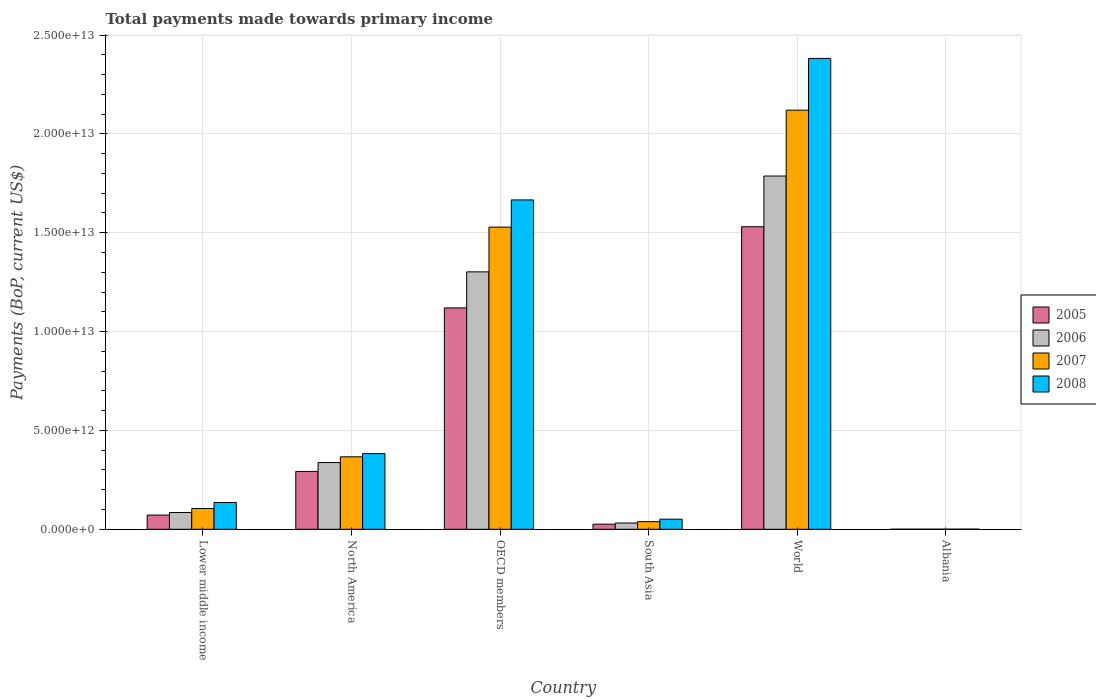How many different coloured bars are there?
Your answer should be very brief. 4. Are the number of bars per tick equal to the number of legend labels?
Give a very brief answer. Yes. What is the label of the 1st group of bars from the left?
Give a very brief answer. Lower middle income. What is the total payments made towards primary income in 2008 in North America?
Keep it short and to the point. 3.83e+12. Across all countries, what is the maximum total payments made towards primary income in 2008?
Your answer should be compact. 2.38e+13. Across all countries, what is the minimum total payments made towards primary income in 2005?
Your answer should be compact. 3.55e+09. In which country was the total payments made towards primary income in 2007 maximum?
Provide a short and direct response. World. In which country was the total payments made towards primary income in 2005 minimum?
Your answer should be very brief. Albania. What is the total total payments made towards primary income in 2006 in the graph?
Your answer should be compact. 3.54e+13. What is the difference between the total payments made towards primary income in 2008 in Albania and that in World?
Keep it short and to the point. -2.38e+13. What is the difference between the total payments made towards primary income in 2006 in North America and the total payments made towards primary income in 2005 in World?
Ensure brevity in your answer.  -1.19e+13. What is the average total payments made towards primary income in 2006 per country?
Give a very brief answer. 5.91e+12. What is the difference between the total payments made towards primary income of/in 2006 and total payments made towards primary income of/in 2007 in OECD members?
Your answer should be compact. -2.26e+12. In how many countries, is the total payments made towards primary income in 2005 greater than 18000000000000 US$?
Provide a succinct answer. 0. What is the ratio of the total payments made towards primary income in 2006 in North America to that in World?
Your response must be concise. 0.19. Is the difference between the total payments made towards primary income in 2006 in Lower middle income and North America greater than the difference between the total payments made towards primary income in 2007 in Lower middle income and North America?
Your response must be concise. Yes. What is the difference between the highest and the second highest total payments made towards primary income in 2005?
Your answer should be very brief. 8.27e+12. What is the difference between the highest and the lowest total payments made towards primary income in 2006?
Give a very brief answer. 1.79e+13. In how many countries, is the total payments made towards primary income in 2007 greater than the average total payments made towards primary income in 2007 taken over all countries?
Your answer should be very brief. 2. Is the sum of the total payments made towards primary income in 2007 in OECD members and World greater than the maximum total payments made towards primary income in 2005 across all countries?
Offer a very short reply. Yes. What does the 2nd bar from the right in South Asia represents?
Your answer should be very brief. 2007. Is it the case that in every country, the sum of the total payments made towards primary income in 2005 and total payments made towards primary income in 2008 is greater than the total payments made towards primary income in 2006?
Your answer should be compact. Yes. How many bars are there?
Ensure brevity in your answer.  24. What is the difference between two consecutive major ticks on the Y-axis?
Keep it short and to the point. 5.00e+12. Does the graph contain any zero values?
Give a very brief answer. No. Does the graph contain grids?
Provide a succinct answer. Yes. Where does the legend appear in the graph?
Your response must be concise. Center right. How many legend labels are there?
Offer a very short reply. 4. How are the legend labels stacked?
Give a very brief answer. Vertical. What is the title of the graph?
Offer a terse response. Total payments made towards primary income. What is the label or title of the Y-axis?
Your answer should be compact. Payments (BoP, current US$). What is the Payments (BoP, current US$) in 2005 in Lower middle income?
Give a very brief answer. 7.19e+11. What is the Payments (BoP, current US$) of 2006 in Lower middle income?
Ensure brevity in your answer.  8.48e+11. What is the Payments (BoP, current US$) in 2007 in Lower middle income?
Your answer should be very brief. 1.05e+12. What is the Payments (BoP, current US$) of 2008 in Lower middle income?
Make the answer very short. 1.35e+12. What is the Payments (BoP, current US$) in 2005 in North America?
Your answer should be compact. 2.93e+12. What is the Payments (BoP, current US$) in 2006 in North America?
Keep it short and to the point. 3.38e+12. What is the Payments (BoP, current US$) in 2007 in North America?
Offer a terse response. 3.67e+12. What is the Payments (BoP, current US$) of 2008 in North America?
Give a very brief answer. 3.83e+12. What is the Payments (BoP, current US$) in 2005 in OECD members?
Provide a succinct answer. 1.12e+13. What is the Payments (BoP, current US$) in 2006 in OECD members?
Give a very brief answer. 1.30e+13. What is the Payments (BoP, current US$) of 2007 in OECD members?
Provide a short and direct response. 1.53e+13. What is the Payments (BoP, current US$) of 2008 in OECD members?
Provide a succinct answer. 1.67e+13. What is the Payments (BoP, current US$) in 2005 in South Asia?
Your answer should be compact. 2.61e+11. What is the Payments (BoP, current US$) of 2006 in South Asia?
Offer a very short reply. 3.18e+11. What is the Payments (BoP, current US$) in 2007 in South Asia?
Ensure brevity in your answer.  3.88e+11. What is the Payments (BoP, current US$) in 2008 in South Asia?
Keep it short and to the point. 5.11e+11. What is the Payments (BoP, current US$) in 2005 in World?
Make the answer very short. 1.53e+13. What is the Payments (BoP, current US$) of 2006 in World?
Provide a succinct answer. 1.79e+13. What is the Payments (BoP, current US$) of 2007 in World?
Provide a short and direct response. 2.12e+13. What is the Payments (BoP, current US$) in 2008 in World?
Your response must be concise. 2.38e+13. What is the Payments (BoP, current US$) of 2005 in Albania?
Your answer should be compact. 3.55e+09. What is the Payments (BoP, current US$) in 2006 in Albania?
Give a very brief answer. 4.14e+09. What is the Payments (BoP, current US$) of 2007 in Albania?
Provide a short and direct response. 5.43e+09. What is the Payments (BoP, current US$) in 2008 in Albania?
Provide a short and direct response. 7.15e+09. Across all countries, what is the maximum Payments (BoP, current US$) of 2005?
Provide a short and direct response. 1.53e+13. Across all countries, what is the maximum Payments (BoP, current US$) of 2006?
Keep it short and to the point. 1.79e+13. Across all countries, what is the maximum Payments (BoP, current US$) of 2007?
Offer a terse response. 2.12e+13. Across all countries, what is the maximum Payments (BoP, current US$) of 2008?
Give a very brief answer. 2.38e+13. Across all countries, what is the minimum Payments (BoP, current US$) of 2005?
Provide a short and direct response. 3.55e+09. Across all countries, what is the minimum Payments (BoP, current US$) in 2006?
Your answer should be compact. 4.14e+09. Across all countries, what is the minimum Payments (BoP, current US$) in 2007?
Your response must be concise. 5.43e+09. Across all countries, what is the minimum Payments (BoP, current US$) of 2008?
Provide a short and direct response. 7.15e+09. What is the total Payments (BoP, current US$) of 2005 in the graph?
Offer a terse response. 3.04e+13. What is the total Payments (BoP, current US$) in 2006 in the graph?
Provide a short and direct response. 3.54e+13. What is the total Payments (BoP, current US$) of 2007 in the graph?
Provide a succinct answer. 4.16e+13. What is the total Payments (BoP, current US$) in 2008 in the graph?
Make the answer very short. 4.62e+13. What is the difference between the Payments (BoP, current US$) in 2005 in Lower middle income and that in North America?
Give a very brief answer. -2.21e+12. What is the difference between the Payments (BoP, current US$) in 2006 in Lower middle income and that in North America?
Provide a short and direct response. -2.53e+12. What is the difference between the Payments (BoP, current US$) of 2007 in Lower middle income and that in North America?
Provide a succinct answer. -2.61e+12. What is the difference between the Payments (BoP, current US$) in 2008 in Lower middle income and that in North America?
Offer a very short reply. -2.47e+12. What is the difference between the Payments (BoP, current US$) in 2005 in Lower middle income and that in OECD members?
Offer a very short reply. -1.05e+13. What is the difference between the Payments (BoP, current US$) of 2006 in Lower middle income and that in OECD members?
Offer a very short reply. -1.22e+13. What is the difference between the Payments (BoP, current US$) of 2007 in Lower middle income and that in OECD members?
Your answer should be very brief. -1.42e+13. What is the difference between the Payments (BoP, current US$) in 2008 in Lower middle income and that in OECD members?
Your answer should be very brief. -1.53e+13. What is the difference between the Payments (BoP, current US$) of 2005 in Lower middle income and that in South Asia?
Make the answer very short. 4.59e+11. What is the difference between the Payments (BoP, current US$) in 2006 in Lower middle income and that in South Asia?
Your answer should be compact. 5.30e+11. What is the difference between the Payments (BoP, current US$) in 2007 in Lower middle income and that in South Asia?
Your answer should be compact. 6.64e+11. What is the difference between the Payments (BoP, current US$) of 2008 in Lower middle income and that in South Asia?
Make the answer very short. 8.43e+11. What is the difference between the Payments (BoP, current US$) in 2005 in Lower middle income and that in World?
Give a very brief answer. -1.46e+13. What is the difference between the Payments (BoP, current US$) of 2006 in Lower middle income and that in World?
Your answer should be compact. -1.70e+13. What is the difference between the Payments (BoP, current US$) in 2007 in Lower middle income and that in World?
Keep it short and to the point. -2.01e+13. What is the difference between the Payments (BoP, current US$) of 2008 in Lower middle income and that in World?
Provide a short and direct response. -2.25e+13. What is the difference between the Payments (BoP, current US$) in 2005 in Lower middle income and that in Albania?
Offer a very short reply. 7.16e+11. What is the difference between the Payments (BoP, current US$) in 2006 in Lower middle income and that in Albania?
Offer a very short reply. 8.44e+11. What is the difference between the Payments (BoP, current US$) of 2007 in Lower middle income and that in Albania?
Offer a very short reply. 1.05e+12. What is the difference between the Payments (BoP, current US$) in 2008 in Lower middle income and that in Albania?
Your answer should be very brief. 1.35e+12. What is the difference between the Payments (BoP, current US$) in 2005 in North America and that in OECD members?
Provide a succinct answer. -8.27e+12. What is the difference between the Payments (BoP, current US$) in 2006 in North America and that in OECD members?
Your answer should be compact. -9.65e+12. What is the difference between the Payments (BoP, current US$) of 2007 in North America and that in OECD members?
Make the answer very short. -1.16e+13. What is the difference between the Payments (BoP, current US$) in 2008 in North America and that in OECD members?
Your answer should be very brief. -1.28e+13. What is the difference between the Payments (BoP, current US$) of 2005 in North America and that in South Asia?
Your answer should be very brief. 2.67e+12. What is the difference between the Payments (BoP, current US$) in 2006 in North America and that in South Asia?
Provide a succinct answer. 3.06e+12. What is the difference between the Payments (BoP, current US$) of 2007 in North America and that in South Asia?
Provide a succinct answer. 3.28e+12. What is the difference between the Payments (BoP, current US$) of 2008 in North America and that in South Asia?
Provide a succinct answer. 3.32e+12. What is the difference between the Payments (BoP, current US$) of 2005 in North America and that in World?
Keep it short and to the point. -1.24e+13. What is the difference between the Payments (BoP, current US$) in 2006 in North America and that in World?
Keep it short and to the point. -1.45e+13. What is the difference between the Payments (BoP, current US$) in 2007 in North America and that in World?
Your response must be concise. -1.75e+13. What is the difference between the Payments (BoP, current US$) in 2008 in North America and that in World?
Your answer should be compact. -2.00e+13. What is the difference between the Payments (BoP, current US$) of 2005 in North America and that in Albania?
Provide a succinct answer. 2.92e+12. What is the difference between the Payments (BoP, current US$) in 2006 in North America and that in Albania?
Offer a terse response. 3.37e+12. What is the difference between the Payments (BoP, current US$) in 2007 in North America and that in Albania?
Give a very brief answer. 3.66e+12. What is the difference between the Payments (BoP, current US$) in 2008 in North America and that in Albania?
Keep it short and to the point. 3.82e+12. What is the difference between the Payments (BoP, current US$) of 2005 in OECD members and that in South Asia?
Offer a very short reply. 1.09e+13. What is the difference between the Payments (BoP, current US$) in 2006 in OECD members and that in South Asia?
Offer a terse response. 1.27e+13. What is the difference between the Payments (BoP, current US$) in 2007 in OECD members and that in South Asia?
Offer a terse response. 1.49e+13. What is the difference between the Payments (BoP, current US$) in 2008 in OECD members and that in South Asia?
Your answer should be very brief. 1.61e+13. What is the difference between the Payments (BoP, current US$) in 2005 in OECD members and that in World?
Offer a very short reply. -4.11e+12. What is the difference between the Payments (BoP, current US$) of 2006 in OECD members and that in World?
Offer a very short reply. -4.85e+12. What is the difference between the Payments (BoP, current US$) of 2007 in OECD members and that in World?
Provide a short and direct response. -5.91e+12. What is the difference between the Payments (BoP, current US$) in 2008 in OECD members and that in World?
Your answer should be very brief. -7.16e+12. What is the difference between the Payments (BoP, current US$) in 2005 in OECD members and that in Albania?
Provide a succinct answer. 1.12e+13. What is the difference between the Payments (BoP, current US$) of 2006 in OECD members and that in Albania?
Ensure brevity in your answer.  1.30e+13. What is the difference between the Payments (BoP, current US$) in 2007 in OECD members and that in Albania?
Your answer should be compact. 1.53e+13. What is the difference between the Payments (BoP, current US$) in 2008 in OECD members and that in Albania?
Provide a succinct answer. 1.67e+13. What is the difference between the Payments (BoP, current US$) in 2005 in South Asia and that in World?
Your response must be concise. -1.50e+13. What is the difference between the Payments (BoP, current US$) of 2006 in South Asia and that in World?
Your answer should be compact. -1.75e+13. What is the difference between the Payments (BoP, current US$) in 2007 in South Asia and that in World?
Provide a short and direct response. -2.08e+13. What is the difference between the Payments (BoP, current US$) of 2008 in South Asia and that in World?
Your answer should be very brief. -2.33e+13. What is the difference between the Payments (BoP, current US$) in 2005 in South Asia and that in Albania?
Ensure brevity in your answer.  2.57e+11. What is the difference between the Payments (BoP, current US$) in 2006 in South Asia and that in Albania?
Your answer should be compact. 3.14e+11. What is the difference between the Payments (BoP, current US$) in 2007 in South Asia and that in Albania?
Offer a terse response. 3.82e+11. What is the difference between the Payments (BoP, current US$) in 2008 in South Asia and that in Albania?
Keep it short and to the point. 5.04e+11. What is the difference between the Payments (BoP, current US$) in 2005 in World and that in Albania?
Make the answer very short. 1.53e+13. What is the difference between the Payments (BoP, current US$) of 2006 in World and that in Albania?
Your response must be concise. 1.79e+13. What is the difference between the Payments (BoP, current US$) in 2007 in World and that in Albania?
Provide a short and direct response. 2.12e+13. What is the difference between the Payments (BoP, current US$) in 2008 in World and that in Albania?
Offer a terse response. 2.38e+13. What is the difference between the Payments (BoP, current US$) in 2005 in Lower middle income and the Payments (BoP, current US$) in 2006 in North America?
Provide a succinct answer. -2.66e+12. What is the difference between the Payments (BoP, current US$) of 2005 in Lower middle income and the Payments (BoP, current US$) of 2007 in North America?
Your answer should be compact. -2.95e+12. What is the difference between the Payments (BoP, current US$) in 2005 in Lower middle income and the Payments (BoP, current US$) in 2008 in North America?
Offer a terse response. -3.11e+12. What is the difference between the Payments (BoP, current US$) of 2006 in Lower middle income and the Payments (BoP, current US$) of 2007 in North America?
Your answer should be compact. -2.82e+12. What is the difference between the Payments (BoP, current US$) of 2006 in Lower middle income and the Payments (BoP, current US$) of 2008 in North America?
Your answer should be very brief. -2.98e+12. What is the difference between the Payments (BoP, current US$) of 2007 in Lower middle income and the Payments (BoP, current US$) of 2008 in North America?
Keep it short and to the point. -2.78e+12. What is the difference between the Payments (BoP, current US$) of 2005 in Lower middle income and the Payments (BoP, current US$) of 2006 in OECD members?
Give a very brief answer. -1.23e+13. What is the difference between the Payments (BoP, current US$) in 2005 in Lower middle income and the Payments (BoP, current US$) in 2007 in OECD members?
Provide a succinct answer. -1.46e+13. What is the difference between the Payments (BoP, current US$) of 2005 in Lower middle income and the Payments (BoP, current US$) of 2008 in OECD members?
Your answer should be compact. -1.59e+13. What is the difference between the Payments (BoP, current US$) in 2006 in Lower middle income and the Payments (BoP, current US$) in 2007 in OECD members?
Your answer should be compact. -1.44e+13. What is the difference between the Payments (BoP, current US$) of 2006 in Lower middle income and the Payments (BoP, current US$) of 2008 in OECD members?
Offer a terse response. -1.58e+13. What is the difference between the Payments (BoP, current US$) of 2007 in Lower middle income and the Payments (BoP, current US$) of 2008 in OECD members?
Make the answer very short. -1.56e+13. What is the difference between the Payments (BoP, current US$) of 2005 in Lower middle income and the Payments (BoP, current US$) of 2006 in South Asia?
Ensure brevity in your answer.  4.01e+11. What is the difference between the Payments (BoP, current US$) of 2005 in Lower middle income and the Payments (BoP, current US$) of 2007 in South Asia?
Offer a terse response. 3.32e+11. What is the difference between the Payments (BoP, current US$) in 2005 in Lower middle income and the Payments (BoP, current US$) in 2008 in South Asia?
Keep it short and to the point. 2.08e+11. What is the difference between the Payments (BoP, current US$) in 2006 in Lower middle income and the Payments (BoP, current US$) in 2007 in South Asia?
Ensure brevity in your answer.  4.60e+11. What is the difference between the Payments (BoP, current US$) in 2006 in Lower middle income and the Payments (BoP, current US$) in 2008 in South Asia?
Make the answer very short. 3.37e+11. What is the difference between the Payments (BoP, current US$) of 2007 in Lower middle income and the Payments (BoP, current US$) of 2008 in South Asia?
Your answer should be compact. 5.41e+11. What is the difference between the Payments (BoP, current US$) in 2005 in Lower middle income and the Payments (BoP, current US$) in 2006 in World?
Keep it short and to the point. -1.71e+13. What is the difference between the Payments (BoP, current US$) in 2005 in Lower middle income and the Payments (BoP, current US$) in 2007 in World?
Offer a terse response. -2.05e+13. What is the difference between the Payments (BoP, current US$) of 2005 in Lower middle income and the Payments (BoP, current US$) of 2008 in World?
Offer a terse response. -2.31e+13. What is the difference between the Payments (BoP, current US$) of 2006 in Lower middle income and the Payments (BoP, current US$) of 2007 in World?
Your response must be concise. -2.04e+13. What is the difference between the Payments (BoP, current US$) of 2006 in Lower middle income and the Payments (BoP, current US$) of 2008 in World?
Keep it short and to the point. -2.30e+13. What is the difference between the Payments (BoP, current US$) in 2007 in Lower middle income and the Payments (BoP, current US$) in 2008 in World?
Ensure brevity in your answer.  -2.28e+13. What is the difference between the Payments (BoP, current US$) in 2005 in Lower middle income and the Payments (BoP, current US$) in 2006 in Albania?
Your answer should be very brief. 7.15e+11. What is the difference between the Payments (BoP, current US$) in 2005 in Lower middle income and the Payments (BoP, current US$) in 2007 in Albania?
Offer a terse response. 7.14e+11. What is the difference between the Payments (BoP, current US$) of 2005 in Lower middle income and the Payments (BoP, current US$) of 2008 in Albania?
Your answer should be compact. 7.12e+11. What is the difference between the Payments (BoP, current US$) in 2006 in Lower middle income and the Payments (BoP, current US$) in 2007 in Albania?
Ensure brevity in your answer.  8.42e+11. What is the difference between the Payments (BoP, current US$) in 2006 in Lower middle income and the Payments (BoP, current US$) in 2008 in Albania?
Your answer should be compact. 8.41e+11. What is the difference between the Payments (BoP, current US$) in 2007 in Lower middle income and the Payments (BoP, current US$) in 2008 in Albania?
Ensure brevity in your answer.  1.04e+12. What is the difference between the Payments (BoP, current US$) of 2005 in North America and the Payments (BoP, current US$) of 2006 in OECD members?
Your answer should be very brief. -1.01e+13. What is the difference between the Payments (BoP, current US$) of 2005 in North America and the Payments (BoP, current US$) of 2007 in OECD members?
Offer a terse response. -1.24e+13. What is the difference between the Payments (BoP, current US$) in 2005 in North America and the Payments (BoP, current US$) in 2008 in OECD members?
Provide a short and direct response. -1.37e+13. What is the difference between the Payments (BoP, current US$) in 2006 in North America and the Payments (BoP, current US$) in 2007 in OECD members?
Offer a terse response. -1.19e+13. What is the difference between the Payments (BoP, current US$) of 2006 in North America and the Payments (BoP, current US$) of 2008 in OECD members?
Keep it short and to the point. -1.33e+13. What is the difference between the Payments (BoP, current US$) in 2007 in North America and the Payments (BoP, current US$) in 2008 in OECD members?
Provide a short and direct response. -1.30e+13. What is the difference between the Payments (BoP, current US$) in 2005 in North America and the Payments (BoP, current US$) in 2006 in South Asia?
Offer a terse response. 2.61e+12. What is the difference between the Payments (BoP, current US$) of 2005 in North America and the Payments (BoP, current US$) of 2007 in South Asia?
Provide a short and direct response. 2.54e+12. What is the difference between the Payments (BoP, current US$) in 2005 in North America and the Payments (BoP, current US$) in 2008 in South Asia?
Provide a succinct answer. 2.41e+12. What is the difference between the Payments (BoP, current US$) in 2006 in North America and the Payments (BoP, current US$) in 2007 in South Asia?
Offer a very short reply. 2.99e+12. What is the difference between the Payments (BoP, current US$) of 2006 in North America and the Payments (BoP, current US$) of 2008 in South Asia?
Ensure brevity in your answer.  2.86e+12. What is the difference between the Payments (BoP, current US$) of 2007 in North America and the Payments (BoP, current US$) of 2008 in South Asia?
Provide a short and direct response. 3.15e+12. What is the difference between the Payments (BoP, current US$) of 2005 in North America and the Payments (BoP, current US$) of 2006 in World?
Offer a very short reply. -1.49e+13. What is the difference between the Payments (BoP, current US$) of 2005 in North America and the Payments (BoP, current US$) of 2007 in World?
Provide a short and direct response. -1.83e+13. What is the difference between the Payments (BoP, current US$) of 2005 in North America and the Payments (BoP, current US$) of 2008 in World?
Keep it short and to the point. -2.09e+13. What is the difference between the Payments (BoP, current US$) of 2006 in North America and the Payments (BoP, current US$) of 2007 in World?
Offer a very short reply. -1.78e+13. What is the difference between the Payments (BoP, current US$) of 2006 in North America and the Payments (BoP, current US$) of 2008 in World?
Provide a short and direct response. -2.04e+13. What is the difference between the Payments (BoP, current US$) in 2007 in North America and the Payments (BoP, current US$) in 2008 in World?
Your response must be concise. -2.01e+13. What is the difference between the Payments (BoP, current US$) in 2005 in North America and the Payments (BoP, current US$) in 2006 in Albania?
Your response must be concise. 2.92e+12. What is the difference between the Payments (BoP, current US$) in 2005 in North America and the Payments (BoP, current US$) in 2007 in Albania?
Give a very brief answer. 2.92e+12. What is the difference between the Payments (BoP, current US$) in 2005 in North America and the Payments (BoP, current US$) in 2008 in Albania?
Your response must be concise. 2.92e+12. What is the difference between the Payments (BoP, current US$) of 2006 in North America and the Payments (BoP, current US$) of 2007 in Albania?
Provide a succinct answer. 3.37e+12. What is the difference between the Payments (BoP, current US$) in 2006 in North America and the Payments (BoP, current US$) in 2008 in Albania?
Your response must be concise. 3.37e+12. What is the difference between the Payments (BoP, current US$) of 2007 in North America and the Payments (BoP, current US$) of 2008 in Albania?
Ensure brevity in your answer.  3.66e+12. What is the difference between the Payments (BoP, current US$) of 2005 in OECD members and the Payments (BoP, current US$) of 2006 in South Asia?
Your answer should be compact. 1.09e+13. What is the difference between the Payments (BoP, current US$) of 2005 in OECD members and the Payments (BoP, current US$) of 2007 in South Asia?
Offer a very short reply. 1.08e+13. What is the difference between the Payments (BoP, current US$) in 2005 in OECD members and the Payments (BoP, current US$) in 2008 in South Asia?
Offer a terse response. 1.07e+13. What is the difference between the Payments (BoP, current US$) in 2006 in OECD members and the Payments (BoP, current US$) in 2007 in South Asia?
Provide a succinct answer. 1.26e+13. What is the difference between the Payments (BoP, current US$) in 2006 in OECD members and the Payments (BoP, current US$) in 2008 in South Asia?
Make the answer very short. 1.25e+13. What is the difference between the Payments (BoP, current US$) in 2007 in OECD members and the Payments (BoP, current US$) in 2008 in South Asia?
Give a very brief answer. 1.48e+13. What is the difference between the Payments (BoP, current US$) in 2005 in OECD members and the Payments (BoP, current US$) in 2006 in World?
Offer a very short reply. -6.67e+12. What is the difference between the Payments (BoP, current US$) in 2005 in OECD members and the Payments (BoP, current US$) in 2007 in World?
Your answer should be compact. -1.00e+13. What is the difference between the Payments (BoP, current US$) in 2005 in OECD members and the Payments (BoP, current US$) in 2008 in World?
Your answer should be compact. -1.26e+13. What is the difference between the Payments (BoP, current US$) of 2006 in OECD members and the Payments (BoP, current US$) of 2007 in World?
Ensure brevity in your answer.  -8.18e+12. What is the difference between the Payments (BoP, current US$) of 2006 in OECD members and the Payments (BoP, current US$) of 2008 in World?
Your response must be concise. -1.08e+13. What is the difference between the Payments (BoP, current US$) of 2007 in OECD members and the Payments (BoP, current US$) of 2008 in World?
Ensure brevity in your answer.  -8.53e+12. What is the difference between the Payments (BoP, current US$) in 2005 in OECD members and the Payments (BoP, current US$) in 2006 in Albania?
Provide a succinct answer. 1.12e+13. What is the difference between the Payments (BoP, current US$) of 2005 in OECD members and the Payments (BoP, current US$) of 2007 in Albania?
Provide a short and direct response. 1.12e+13. What is the difference between the Payments (BoP, current US$) of 2005 in OECD members and the Payments (BoP, current US$) of 2008 in Albania?
Your answer should be very brief. 1.12e+13. What is the difference between the Payments (BoP, current US$) of 2006 in OECD members and the Payments (BoP, current US$) of 2007 in Albania?
Ensure brevity in your answer.  1.30e+13. What is the difference between the Payments (BoP, current US$) in 2006 in OECD members and the Payments (BoP, current US$) in 2008 in Albania?
Offer a terse response. 1.30e+13. What is the difference between the Payments (BoP, current US$) of 2007 in OECD members and the Payments (BoP, current US$) of 2008 in Albania?
Your response must be concise. 1.53e+13. What is the difference between the Payments (BoP, current US$) in 2005 in South Asia and the Payments (BoP, current US$) in 2006 in World?
Ensure brevity in your answer.  -1.76e+13. What is the difference between the Payments (BoP, current US$) in 2005 in South Asia and the Payments (BoP, current US$) in 2007 in World?
Ensure brevity in your answer.  -2.09e+13. What is the difference between the Payments (BoP, current US$) in 2005 in South Asia and the Payments (BoP, current US$) in 2008 in World?
Provide a succinct answer. -2.36e+13. What is the difference between the Payments (BoP, current US$) of 2006 in South Asia and the Payments (BoP, current US$) of 2007 in World?
Provide a short and direct response. -2.09e+13. What is the difference between the Payments (BoP, current US$) of 2006 in South Asia and the Payments (BoP, current US$) of 2008 in World?
Your answer should be compact. -2.35e+13. What is the difference between the Payments (BoP, current US$) of 2007 in South Asia and the Payments (BoP, current US$) of 2008 in World?
Offer a very short reply. -2.34e+13. What is the difference between the Payments (BoP, current US$) in 2005 in South Asia and the Payments (BoP, current US$) in 2006 in Albania?
Ensure brevity in your answer.  2.56e+11. What is the difference between the Payments (BoP, current US$) in 2005 in South Asia and the Payments (BoP, current US$) in 2007 in Albania?
Provide a short and direct response. 2.55e+11. What is the difference between the Payments (BoP, current US$) in 2005 in South Asia and the Payments (BoP, current US$) in 2008 in Albania?
Your response must be concise. 2.53e+11. What is the difference between the Payments (BoP, current US$) in 2006 in South Asia and the Payments (BoP, current US$) in 2007 in Albania?
Provide a short and direct response. 3.13e+11. What is the difference between the Payments (BoP, current US$) of 2006 in South Asia and the Payments (BoP, current US$) of 2008 in Albania?
Give a very brief answer. 3.11e+11. What is the difference between the Payments (BoP, current US$) in 2007 in South Asia and the Payments (BoP, current US$) in 2008 in Albania?
Ensure brevity in your answer.  3.80e+11. What is the difference between the Payments (BoP, current US$) in 2005 in World and the Payments (BoP, current US$) in 2006 in Albania?
Provide a succinct answer. 1.53e+13. What is the difference between the Payments (BoP, current US$) in 2005 in World and the Payments (BoP, current US$) in 2007 in Albania?
Offer a very short reply. 1.53e+13. What is the difference between the Payments (BoP, current US$) of 2005 in World and the Payments (BoP, current US$) of 2008 in Albania?
Offer a terse response. 1.53e+13. What is the difference between the Payments (BoP, current US$) in 2006 in World and the Payments (BoP, current US$) in 2007 in Albania?
Keep it short and to the point. 1.79e+13. What is the difference between the Payments (BoP, current US$) of 2006 in World and the Payments (BoP, current US$) of 2008 in Albania?
Provide a succinct answer. 1.79e+13. What is the difference between the Payments (BoP, current US$) of 2007 in World and the Payments (BoP, current US$) of 2008 in Albania?
Your answer should be very brief. 2.12e+13. What is the average Payments (BoP, current US$) of 2005 per country?
Provide a succinct answer. 5.07e+12. What is the average Payments (BoP, current US$) in 2006 per country?
Your response must be concise. 5.91e+12. What is the average Payments (BoP, current US$) in 2007 per country?
Ensure brevity in your answer.  6.93e+12. What is the average Payments (BoP, current US$) in 2008 per country?
Provide a short and direct response. 7.70e+12. What is the difference between the Payments (BoP, current US$) in 2005 and Payments (BoP, current US$) in 2006 in Lower middle income?
Keep it short and to the point. -1.29e+11. What is the difference between the Payments (BoP, current US$) in 2005 and Payments (BoP, current US$) in 2007 in Lower middle income?
Provide a succinct answer. -3.33e+11. What is the difference between the Payments (BoP, current US$) in 2005 and Payments (BoP, current US$) in 2008 in Lower middle income?
Provide a short and direct response. -6.35e+11. What is the difference between the Payments (BoP, current US$) of 2006 and Payments (BoP, current US$) of 2007 in Lower middle income?
Keep it short and to the point. -2.04e+11. What is the difference between the Payments (BoP, current US$) in 2006 and Payments (BoP, current US$) in 2008 in Lower middle income?
Offer a terse response. -5.07e+11. What is the difference between the Payments (BoP, current US$) in 2007 and Payments (BoP, current US$) in 2008 in Lower middle income?
Give a very brief answer. -3.03e+11. What is the difference between the Payments (BoP, current US$) in 2005 and Payments (BoP, current US$) in 2006 in North America?
Your response must be concise. -4.49e+11. What is the difference between the Payments (BoP, current US$) in 2005 and Payments (BoP, current US$) in 2007 in North America?
Make the answer very short. -7.40e+11. What is the difference between the Payments (BoP, current US$) in 2005 and Payments (BoP, current US$) in 2008 in North America?
Your response must be concise. -9.02e+11. What is the difference between the Payments (BoP, current US$) of 2006 and Payments (BoP, current US$) of 2007 in North America?
Keep it short and to the point. -2.91e+11. What is the difference between the Payments (BoP, current US$) in 2006 and Payments (BoP, current US$) in 2008 in North America?
Provide a succinct answer. -4.53e+11. What is the difference between the Payments (BoP, current US$) in 2007 and Payments (BoP, current US$) in 2008 in North America?
Ensure brevity in your answer.  -1.62e+11. What is the difference between the Payments (BoP, current US$) of 2005 and Payments (BoP, current US$) of 2006 in OECD members?
Give a very brief answer. -1.82e+12. What is the difference between the Payments (BoP, current US$) in 2005 and Payments (BoP, current US$) in 2007 in OECD members?
Your response must be concise. -4.09e+12. What is the difference between the Payments (BoP, current US$) in 2005 and Payments (BoP, current US$) in 2008 in OECD members?
Offer a very short reply. -5.46e+12. What is the difference between the Payments (BoP, current US$) in 2006 and Payments (BoP, current US$) in 2007 in OECD members?
Your response must be concise. -2.26e+12. What is the difference between the Payments (BoP, current US$) in 2006 and Payments (BoP, current US$) in 2008 in OECD members?
Your response must be concise. -3.64e+12. What is the difference between the Payments (BoP, current US$) of 2007 and Payments (BoP, current US$) of 2008 in OECD members?
Give a very brief answer. -1.38e+12. What is the difference between the Payments (BoP, current US$) in 2005 and Payments (BoP, current US$) in 2006 in South Asia?
Ensure brevity in your answer.  -5.75e+1. What is the difference between the Payments (BoP, current US$) of 2005 and Payments (BoP, current US$) of 2007 in South Asia?
Give a very brief answer. -1.27e+11. What is the difference between the Payments (BoP, current US$) in 2005 and Payments (BoP, current US$) in 2008 in South Asia?
Provide a short and direct response. -2.51e+11. What is the difference between the Payments (BoP, current US$) of 2006 and Payments (BoP, current US$) of 2007 in South Asia?
Ensure brevity in your answer.  -6.95e+1. What is the difference between the Payments (BoP, current US$) in 2006 and Payments (BoP, current US$) in 2008 in South Asia?
Your answer should be compact. -1.93e+11. What is the difference between the Payments (BoP, current US$) of 2007 and Payments (BoP, current US$) of 2008 in South Asia?
Make the answer very short. -1.24e+11. What is the difference between the Payments (BoP, current US$) in 2005 and Payments (BoP, current US$) in 2006 in World?
Keep it short and to the point. -2.56e+12. What is the difference between the Payments (BoP, current US$) in 2005 and Payments (BoP, current US$) in 2007 in World?
Ensure brevity in your answer.  -5.89e+12. What is the difference between the Payments (BoP, current US$) of 2005 and Payments (BoP, current US$) of 2008 in World?
Your answer should be compact. -8.51e+12. What is the difference between the Payments (BoP, current US$) in 2006 and Payments (BoP, current US$) in 2007 in World?
Give a very brief answer. -3.33e+12. What is the difference between the Payments (BoP, current US$) of 2006 and Payments (BoP, current US$) of 2008 in World?
Your answer should be very brief. -5.95e+12. What is the difference between the Payments (BoP, current US$) of 2007 and Payments (BoP, current US$) of 2008 in World?
Keep it short and to the point. -2.62e+12. What is the difference between the Payments (BoP, current US$) in 2005 and Payments (BoP, current US$) in 2006 in Albania?
Keep it short and to the point. -5.89e+08. What is the difference between the Payments (BoP, current US$) in 2005 and Payments (BoP, current US$) in 2007 in Albania?
Provide a short and direct response. -1.88e+09. What is the difference between the Payments (BoP, current US$) in 2005 and Payments (BoP, current US$) in 2008 in Albania?
Ensure brevity in your answer.  -3.60e+09. What is the difference between the Payments (BoP, current US$) in 2006 and Payments (BoP, current US$) in 2007 in Albania?
Your answer should be very brief. -1.29e+09. What is the difference between the Payments (BoP, current US$) in 2006 and Payments (BoP, current US$) in 2008 in Albania?
Give a very brief answer. -3.01e+09. What is the difference between the Payments (BoP, current US$) in 2007 and Payments (BoP, current US$) in 2008 in Albania?
Provide a succinct answer. -1.72e+09. What is the ratio of the Payments (BoP, current US$) in 2005 in Lower middle income to that in North America?
Give a very brief answer. 0.25. What is the ratio of the Payments (BoP, current US$) of 2006 in Lower middle income to that in North America?
Provide a short and direct response. 0.25. What is the ratio of the Payments (BoP, current US$) of 2007 in Lower middle income to that in North America?
Your answer should be compact. 0.29. What is the ratio of the Payments (BoP, current US$) in 2008 in Lower middle income to that in North America?
Your response must be concise. 0.35. What is the ratio of the Payments (BoP, current US$) of 2005 in Lower middle income to that in OECD members?
Keep it short and to the point. 0.06. What is the ratio of the Payments (BoP, current US$) in 2006 in Lower middle income to that in OECD members?
Keep it short and to the point. 0.07. What is the ratio of the Payments (BoP, current US$) of 2007 in Lower middle income to that in OECD members?
Your response must be concise. 0.07. What is the ratio of the Payments (BoP, current US$) in 2008 in Lower middle income to that in OECD members?
Provide a short and direct response. 0.08. What is the ratio of the Payments (BoP, current US$) of 2005 in Lower middle income to that in South Asia?
Provide a succinct answer. 2.76. What is the ratio of the Payments (BoP, current US$) in 2006 in Lower middle income to that in South Asia?
Offer a terse response. 2.67. What is the ratio of the Payments (BoP, current US$) in 2007 in Lower middle income to that in South Asia?
Your answer should be very brief. 2.71. What is the ratio of the Payments (BoP, current US$) in 2008 in Lower middle income to that in South Asia?
Your answer should be compact. 2.65. What is the ratio of the Payments (BoP, current US$) of 2005 in Lower middle income to that in World?
Give a very brief answer. 0.05. What is the ratio of the Payments (BoP, current US$) in 2006 in Lower middle income to that in World?
Ensure brevity in your answer.  0.05. What is the ratio of the Payments (BoP, current US$) in 2007 in Lower middle income to that in World?
Offer a terse response. 0.05. What is the ratio of the Payments (BoP, current US$) of 2008 in Lower middle income to that in World?
Make the answer very short. 0.06. What is the ratio of the Payments (BoP, current US$) in 2005 in Lower middle income to that in Albania?
Give a very brief answer. 202.41. What is the ratio of the Payments (BoP, current US$) in 2006 in Lower middle income to that in Albania?
Offer a very short reply. 204.66. What is the ratio of the Payments (BoP, current US$) in 2007 in Lower middle income to that in Albania?
Make the answer very short. 193.73. What is the ratio of the Payments (BoP, current US$) in 2008 in Lower middle income to that in Albania?
Your answer should be very brief. 189.46. What is the ratio of the Payments (BoP, current US$) in 2005 in North America to that in OECD members?
Give a very brief answer. 0.26. What is the ratio of the Payments (BoP, current US$) in 2006 in North America to that in OECD members?
Your response must be concise. 0.26. What is the ratio of the Payments (BoP, current US$) of 2007 in North America to that in OECD members?
Give a very brief answer. 0.24. What is the ratio of the Payments (BoP, current US$) of 2008 in North America to that in OECD members?
Ensure brevity in your answer.  0.23. What is the ratio of the Payments (BoP, current US$) of 2005 in North America to that in South Asia?
Ensure brevity in your answer.  11.23. What is the ratio of the Payments (BoP, current US$) in 2006 in North America to that in South Asia?
Keep it short and to the point. 10.61. What is the ratio of the Payments (BoP, current US$) in 2007 in North America to that in South Asia?
Offer a terse response. 9.46. What is the ratio of the Payments (BoP, current US$) of 2008 in North America to that in South Asia?
Provide a succinct answer. 7.49. What is the ratio of the Payments (BoP, current US$) of 2005 in North America to that in World?
Offer a terse response. 0.19. What is the ratio of the Payments (BoP, current US$) of 2006 in North America to that in World?
Ensure brevity in your answer.  0.19. What is the ratio of the Payments (BoP, current US$) of 2007 in North America to that in World?
Offer a very short reply. 0.17. What is the ratio of the Payments (BoP, current US$) in 2008 in North America to that in World?
Your answer should be compact. 0.16. What is the ratio of the Payments (BoP, current US$) of 2005 in North America to that in Albania?
Offer a terse response. 823.59. What is the ratio of the Payments (BoP, current US$) of 2006 in North America to that in Albania?
Offer a terse response. 814.9. What is the ratio of the Payments (BoP, current US$) in 2007 in North America to that in Albania?
Offer a terse response. 675.24. What is the ratio of the Payments (BoP, current US$) of 2008 in North America to that in Albania?
Make the answer very short. 535.52. What is the ratio of the Payments (BoP, current US$) in 2005 in OECD members to that in South Asia?
Your answer should be very brief. 42.99. What is the ratio of the Payments (BoP, current US$) in 2006 in OECD members to that in South Asia?
Offer a very short reply. 40.95. What is the ratio of the Payments (BoP, current US$) in 2007 in OECD members to that in South Asia?
Keep it short and to the point. 39.44. What is the ratio of the Payments (BoP, current US$) of 2008 in OECD members to that in South Asia?
Your answer should be very brief. 32.59. What is the ratio of the Payments (BoP, current US$) in 2005 in OECD members to that in World?
Offer a terse response. 0.73. What is the ratio of the Payments (BoP, current US$) of 2006 in OECD members to that in World?
Your answer should be very brief. 0.73. What is the ratio of the Payments (BoP, current US$) in 2007 in OECD members to that in World?
Offer a terse response. 0.72. What is the ratio of the Payments (BoP, current US$) in 2008 in OECD members to that in World?
Give a very brief answer. 0.7. What is the ratio of the Payments (BoP, current US$) of 2005 in OECD members to that in Albania?
Give a very brief answer. 3151.7. What is the ratio of the Payments (BoP, current US$) of 2006 in OECD members to that in Albania?
Offer a very short reply. 3143.4. What is the ratio of the Payments (BoP, current US$) in 2007 in OECD members to that in Albania?
Offer a very short reply. 2815.12. What is the ratio of the Payments (BoP, current US$) in 2008 in OECD members to that in Albania?
Make the answer very short. 2330.28. What is the ratio of the Payments (BoP, current US$) in 2005 in South Asia to that in World?
Ensure brevity in your answer.  0.02. What is the ratio of the Payments (BoP, current US$) of 2006 in South Asia to that in World?
Your answer should be very brief. 0.02. What is the ratio of the Payments (BoP, current US$) in 2007 in South Asia to that in World?
Keep it short and to the point. 0.02. What is the ratio of the Payments (BoP, current US$) in 2008 in South Asia to that in World?
Provide a short and direct response. 0.02. What is the ratio of the Payments (BoP, current US$) in 2005 in South Asia to that in Albania?
Provide a short and direct response. 73.32. What is the ratio of the Payments (BoP, current US$) in 2006 in South Asia to that in Albania?
Your answer should be compact. 76.77. What is the ratio of the Payments (BoP, current US$) of 2007 in South Asia to that in Albania?
Offer a very short reply. 71.38. What is the ratio of the Payments (BoP, current US$) in 2008 in South Asia to that in Albania?
Provide a succinct answer. 71.51. What is the ratio of the Payments (BoP, current US$) of 2005 in World to that in Albania?
Give a very brief answer. 4307.27. What is the ratio of the Payments (BoP, current US$) of 2006 in World to that in Albania?
Make the answer very short. 4313.61. What is the ratio of the Payments (BoP, current US$) in 2007 in World to that in Albania?
Offer a very short reply. 3904.49. What is the ratio of the Payments (BoP, current US$) in 2008 in World to that in Albania?
Offer a terse response. 3331.38. What is the difference between the highest and the second highest Payments (BoP, current US$) of 2005?
Your answer should be compact. 4.11e+12. What is the difference between the highest and the second highest Payments (BoP, current US$) of 2006?
Give a very brief answer. 4.85e+12. What is the difference between the highest and the second highest Payments (BoP, current US$) in 2007?
Keep it short and to the point. 5.91e+12. What is the difference between the highest and the second highest Payments (BoP, current US$) in 2008?
Ensure brevity in your answer.  7.16e+12. What is the difference between the highest and the lowest Payments (BoP, current US$) in 2005?
Make the answer very short. 1.53e+13. What is the difference between the highest and the lowest Payments (BoP, current US$) of 2006?
Provide a succinct answer. 1.79e+13. What is the difference between the highest and the lowest Payments (BoP, current US$) in 2007?
Offer a very short reply. 2.12e+13. What is the difference between the highest and the lowest Payments (BoP, current US$) of 2008?
Provide a succinct answer. 2.38e+13. 